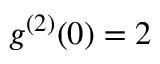<formula> <loc_0><loc_0><loc_500><loc_500>g ^ { ( 2 ) } ( 0 ) = 2</formula> 